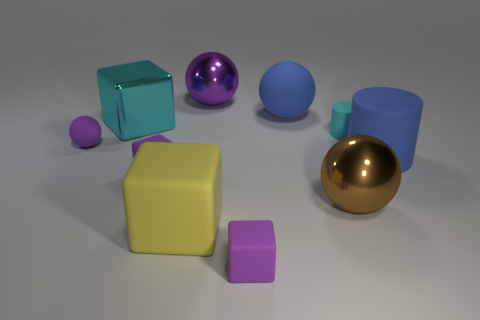Subtract all big matte blocks. How many blocks are left? 3 Subtract all gray spheres. How many purple cubes are left? 2 Subtract 2 cubes. How many cubes are left? 2 Subtract all blue cylinders. How many cylinders are left? 1 Subtract all spheres. How many objects are left? 6 Subtract all purple cylinders. Subtract all green blocks. How many cylinders are left? 2 Subtract all red cylinders. Subtract all purple balls. How many objects are left? 8 Add 5 cyan cubes. How many cyan cubes are left? 6 Add 1 small red balls. How many small red balls exist? 1 Subtract 0 gray balls. How many objects are left? 10 